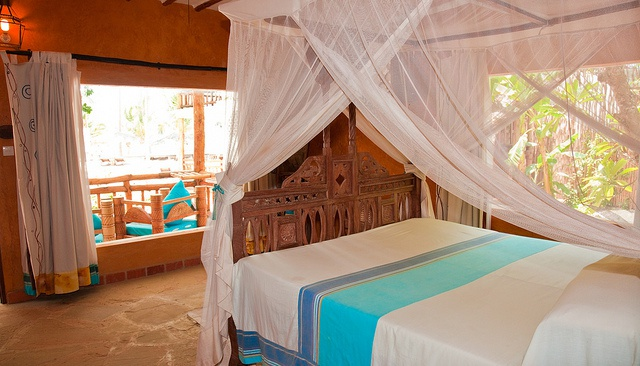Describe the objects in this image and their specific colors. I can see bed in black, tan, darkgray, and maroon tones and chair in black, brown, red, and salmon tones in this image. 